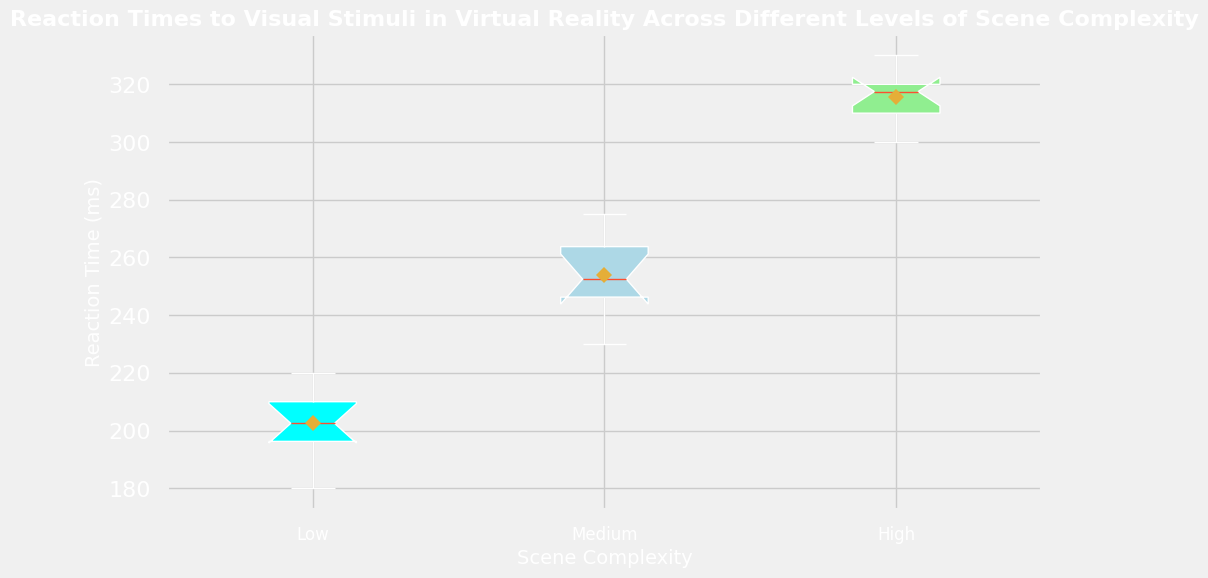What is the median reaction time for the 'High' scene complexity? Locate the box plot for 'High' scene complexity. The median is represented by the line inside the box. It is around 315 ms.
Answer: 315 ms Which scene complexity has the highest mean reaction time? Identify the diamond markers as they represent the mean reaction times. The 'High' scene complexity has the diamond marker at the highest position compared to 'Low' and 'Medium'.
Answer: High Compare the interquartile ranges (IQR) of 'Low' and 'Medium' scene complexity. Which one is larger? The IQR is the range between the lower and upper quartile (the bottom and top edges of the box). The 'Medium' scene complexity box is taller than the 'Low' scene complexity box, indicating a larger IQR.
Answer: Medium How many outliers are present in the 'Low' scene complexity? Outliers are represented by individual points outside the whiskers of the box plot. For 'Low' scene complexity, there are no points outside the whiskers.
Answer: 0 Is the notch in the box plot for 'Medium' scene complexity overlapping with High scene complexity? The notch represents the confidence interval of the median. Check to see if the notches of 'Medium' and 'High' overlap. They do not overlap.
Answer: No Which scene complexity shows the most skewed reaction time distribution? Skewness can be inferred from the shape of the box and the length of the whiskers. The 'High' scene complexity has a noticeable skew towards higher values, with a longer whisker on the upper side.
Answer: High What is the approximate difference between the median reaction times of 'Low' and 'Medium' scene complexities? Identify the medians of 'Low' and 'Medium' by the lines inside the boxes. The medians are around 200 ms for 'Low' and 250 ms for 'Medium'. The difference is 250 - 200 = 50 ms.
Answer: 50 ms How do the mean reaction times in 'Low' and 'High' scene complexity compare? The mean is indicated by the diamond marker. The 'High' complexity's mean is significantly higher than the 'Low' complexity's mean.
Answer: Higher in 'High' 